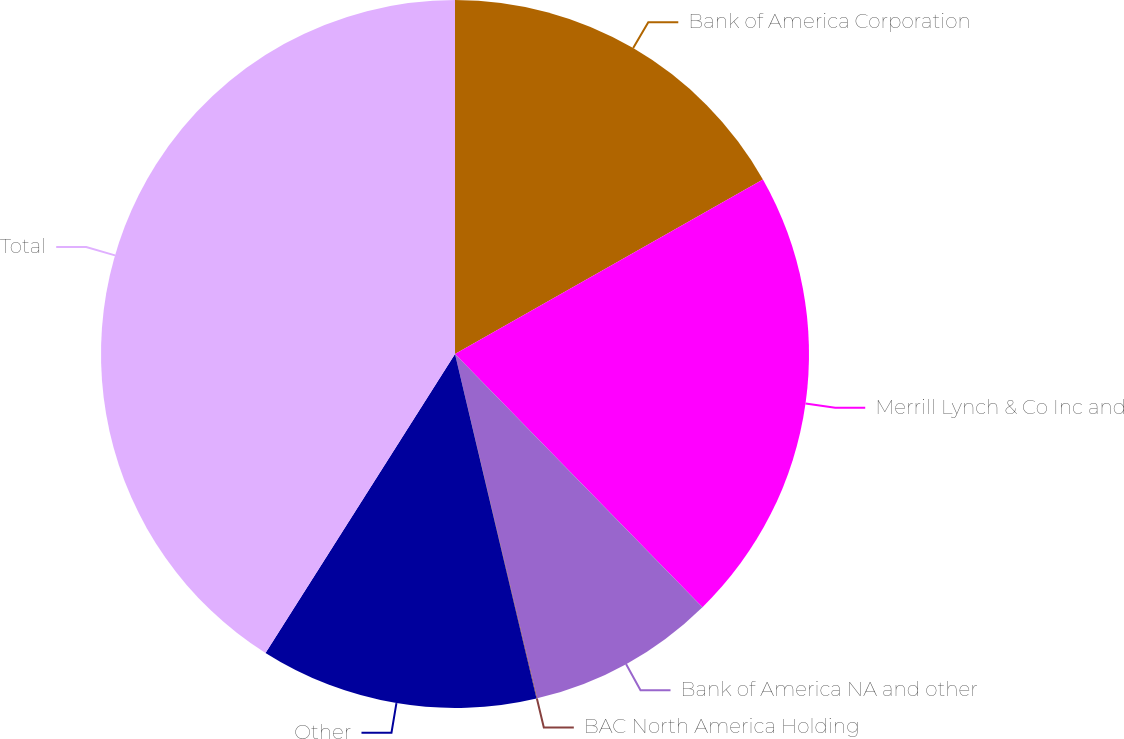<chart> <loc_0><loc_0><loc_500><loc_500><pie_chart><fcel>Bank of America Corporation<fcel>Merrill Lynch & Co Inc and<fcel>Bank of America NA and other<fcel>BAC North America Holding<fcel>Other<fcel>Total<nl><fcel>16.79%<fcel>20.89%<fcel>8.59%<fcel>0.03%<fcel>12.69%<fcel>41.01%<nl></chart> 